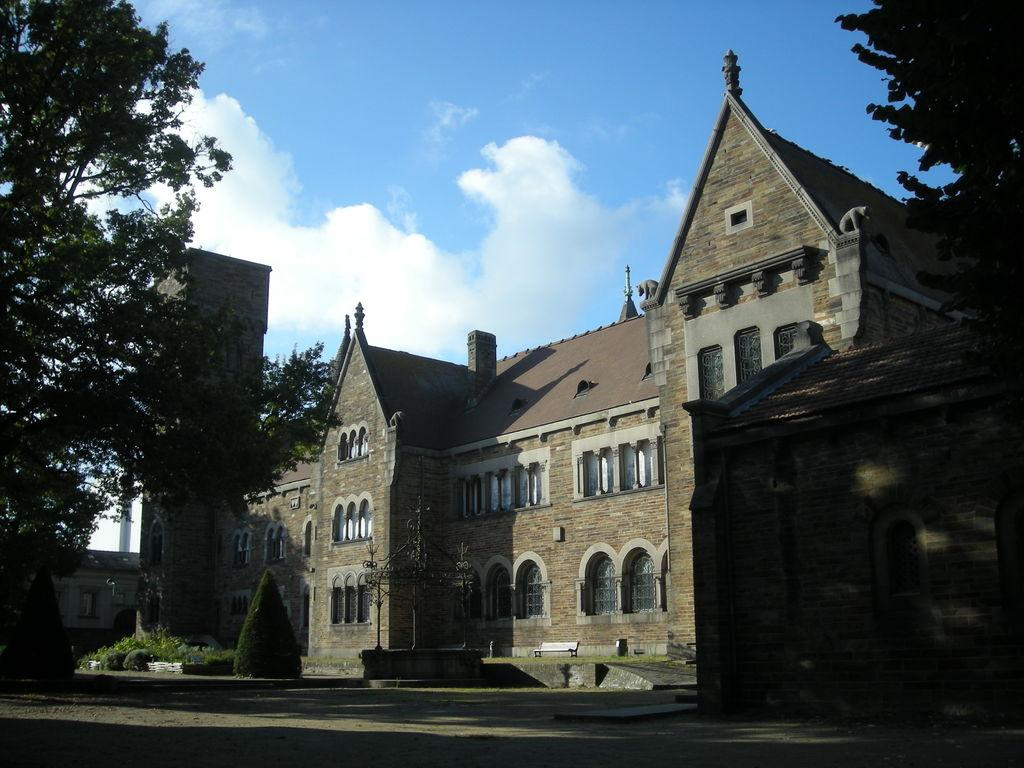What is located in the front of the image? There are leaves in the front of the image. What can be seen in the background of the image? There are buildings and plants in the background of the image. What is the condition of the sky in the background of the image? The sky is cloudy in the background of the image. Can you describe the ocean in the image? There is no ocean present in the image; it features leaves in the front and buildings and plants in the background. 